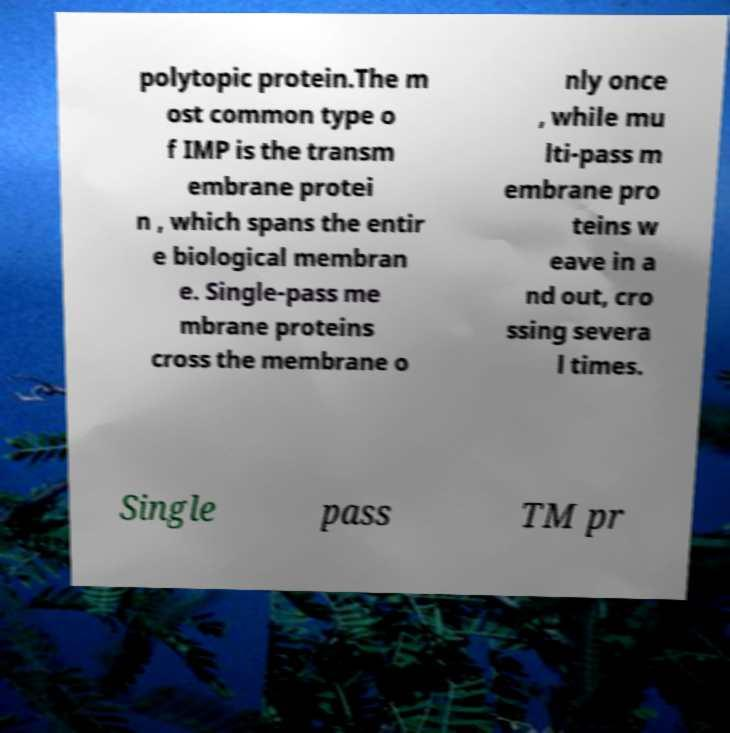What messages or text are displayed in this image? I need them in a readable, typed format. polytopic protein.The m ost common type o f IMP is the transm embrane protei n , which spans the entir e biological membran e. Single-pass me mbrane proteins cross the membrane o nly once , while mu lti-pass m embrane pro teins w eave in a nd out, cro ssing severa l times. Single pass TM pr 